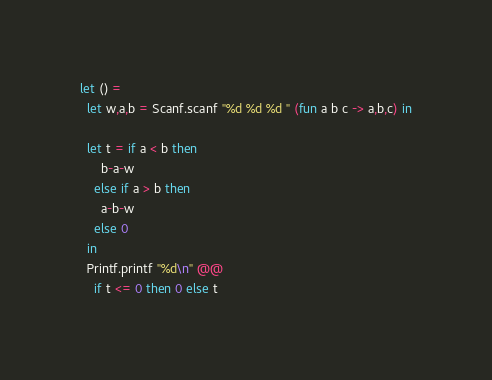Convert code to text. <code><loc_0><loc_0><loc_500><loc_500><_OCaml_>let () =
  let w,a,b = Scanf.scanf "%d %d %d " (fun a b c -> a,b,c) in

  let t = if a < b then
      b-a-w
    else if a > b then
      a-b-w
    else 0
  in
  Printf.printf "%d\n" @@
    if t <= 0 then 0 else t
</code> 